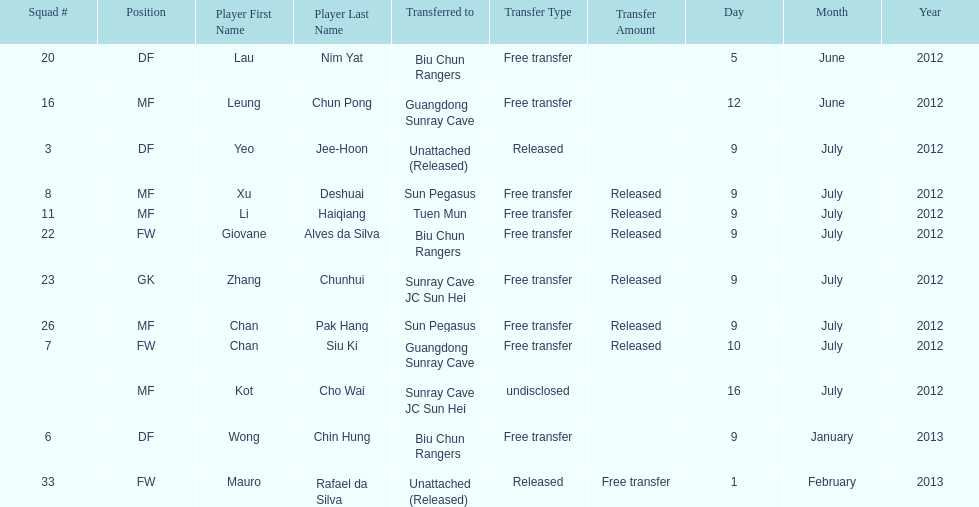How many total players were transferred to sun pegasus? 2. 